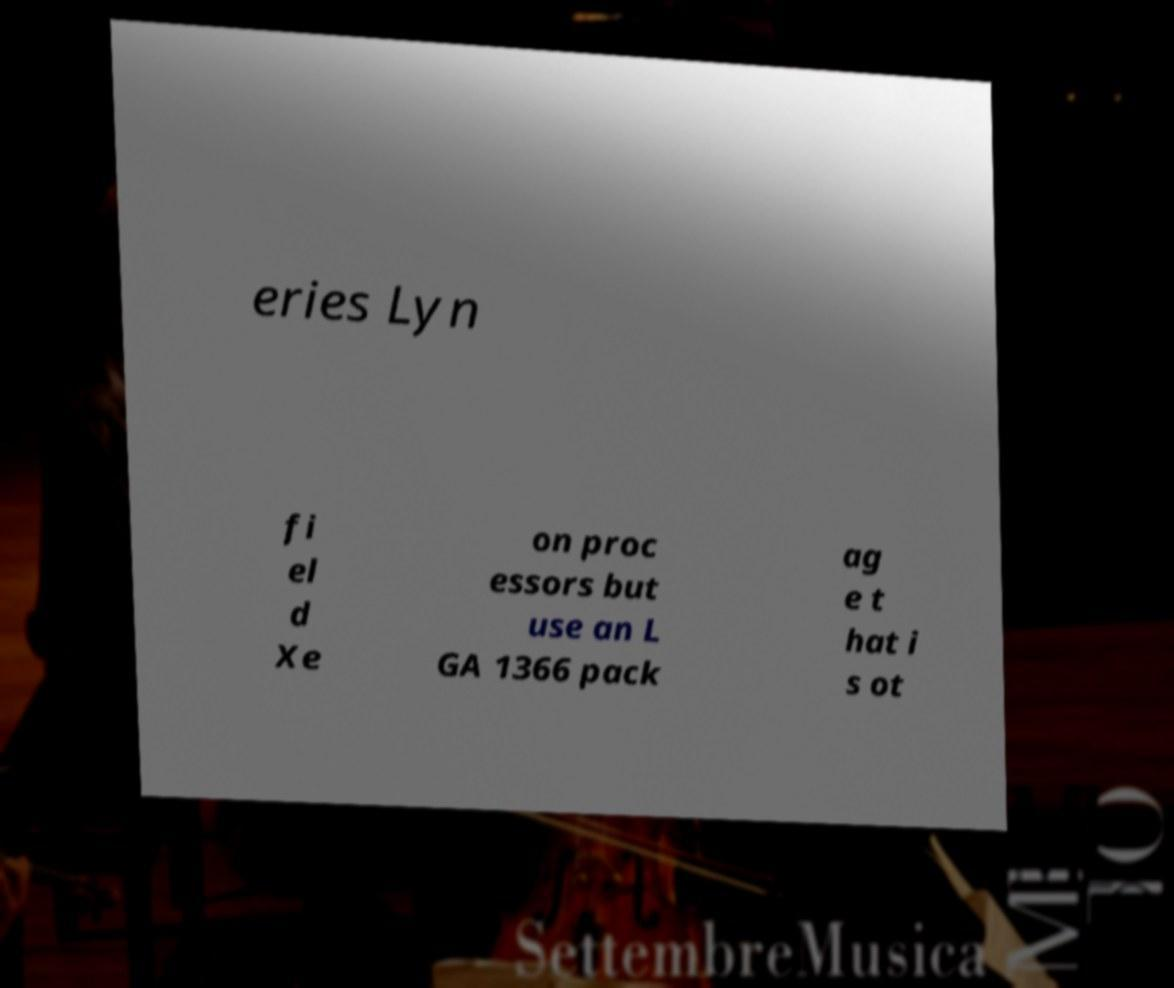For documentation purposes, I need the text within this image transcribed. Could you provide that? eries Lyn fi el d Xe on proc essors but use an L GA 1366 pack ag e t hat i s ot 